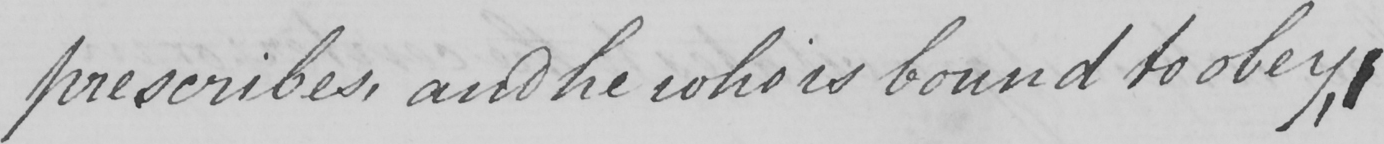Please transcribe the handwritten text in this image. prescribes , and he who is bound to obey , 